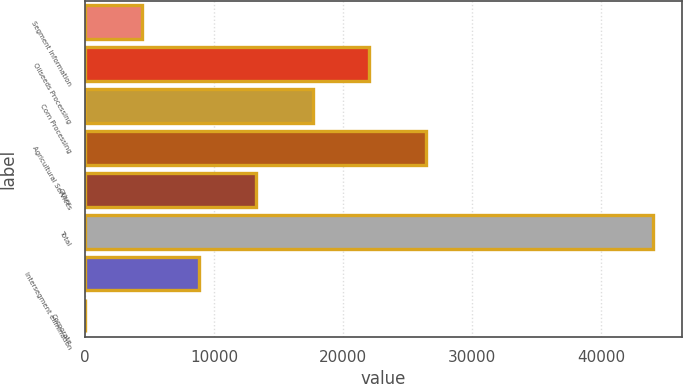Convert chart. <chart><loc_0><loc_0><loc_500><loc_500><bar_chart><fcel>Segment Information<fcel>Oilseeds Processing<fcel>Corn Processing<fcel>Agricultural Services<fcel>Other<fcel>Total<fcel>Intersegment elimination<fcel>Corporate<nl><fcel>4422.5<fcel>22020.5<fcel>17621<fcel>26420<fcel>13221.5<fcel>44018<fcel>8822<fcel>23<nl></chart> 